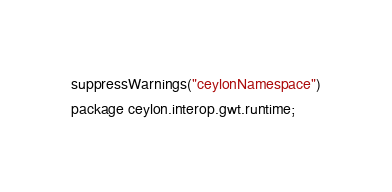<code> <loc_0><loc_0><loc_500><loc_500><_Ceylon_>suppressWarnings("ceylonNamespace")
package ceylon.interop.gwt.runtime;
</code> 